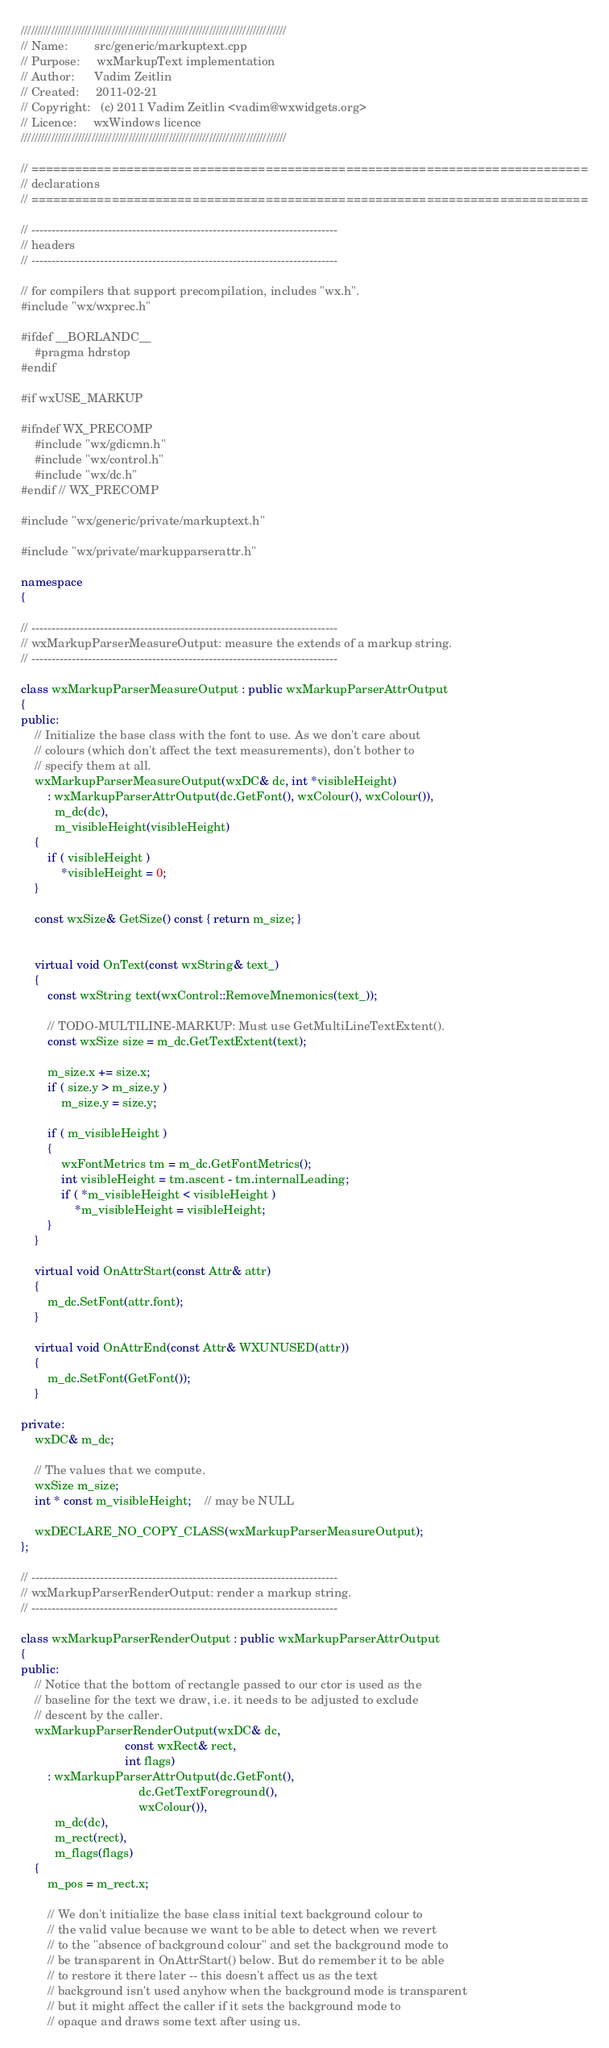<code> <loc_0><loc_0><loc_500><loc_500><_C++_>///////////////////////////////////////////////////////////////////////////////
// Name:        src/generic/markuptext.cpp
// Purpose:     wxMarkupText implementation
// Author:      Vadim Zeitlin
// Created:     2011-02-21
// Copyright:   (c) 2011 Vadim Zeitlin <vadim@wxwidgets.org>
// Licence:     wxWindows licence
///////////////////////////////////////////////////////////////////////////////

// ============================================================================
// declarations
// ============================================================================

// ----------------------------------------------------------------------------
// headers
// ----------------------------------------------------------------------------

// for compilers that support precompilation, includes "wx.h".
#include "wx/wxprec.h"

#ifdef __BORLANDC__
    #pragma hdrstop
#endif

#if wxUSE_MARKUP

#ifndef WX_PRECOMP
    #include "wx/gdicmn.h"
    #include "wx/control.h"
    #include "wx/dc.h"
#endif // WX_PRECOMP

#include "wx/generic/private/markuptext.h"

#include "wx/private/markupparserattr.h"

namespace
{

// ----------------------------------------------------------------------------
// wxMarkupParserMeasureOutput: measure the extends of a markup string.
// ----------------------------------------------------------------------------

class wxMarkupParserMeasureOutput : public wxMarkupParserAttrOutput
{
public:
    // Initialize the base class with the font to use. As we don't care about
    // colours (which don't affect the text measurements), don't bother to
    // specify them at all.
    wxMarkupParserMeasureOutput(wxDC& dc, int *visibleHeight)
        : wxMarkupParserAttrOutput(dc.GetFont(), wxColour(), wxColour()),
          m_dc(dc),
          m_visibleHeight(visibleHeight)
    {
        if ( visibleHeight )
            *visibleHeight = 0;
    }

    const wxSize& GetSize() const { return m_size; }


    virtual void OnText(const wxString& text_)
    {
        const wxString text(wxControl::RemoveMnemonics(text_));

        // TODO-MULTILINE-MARKUP: Must use GetMultiLineTextExtent().
        const wxSize size = m_dc.GetTextExtent(text);

        m_size.x += size.x;
        if ( size.y > m_size.y )
            m_size.y = size.y;

        if ( m_visibleHeight )
        {
            wxFontMetrics tm = m_dc.GetFontMetrics();
            int visibleHeight = tm.ascent - tm.internalLeading;
            if ( *m_visibleHeight < visibleHeight )
                *m_visibleHeight = visibleHeight;
        }
    }

    virtual void OnAttrStart(const Attr& attr)
    {
        m_dc.SetFont(attr.font);
    }

    virtual void OnAttrEnd(const Attr& WXUNUSED(attr))
    {
        m_dc.SetFont(GetFont());
    }

private:
    wxDC& m_dc;

    // The values that we compute.
    wxSize m_size;
    int * const m_visibleHeight;    // may be NULL

    wxDECLARE_NO_COPY_CLASS(wxMarkupParserMeasureOutput);
};

// ----------------------------------------------------------------------------
// wxMarkupParserRenderOutput: render a markup string.
// ----------------------------------------------------------------------------

class wxMarkupParserRenderOutput : public wxMarkupParserAttrOutput
{
public:
    // Notice that the bottom of rectangle passed to our ctor is used as the
    // baseline for the text we draw, i.e. it needs to be adjusted to exclude
    // descent by the caller.
    wxMarkupParserRenderOutput(wxDC& dc,
                               const wxRect& rect,
                               int flags)
        : wxMarkupParserAttrOutput(dc.GetFont(),
                                   dc.GetTextForeground(),
                                   wxColour()),
          m_dc(dc),
          m_rect(rect),
          m_flags(flags)
    {
        m_pos = m_rect.x;

        // We don't initialize the base class initial text background colour to
        // the valid value because we want to be able to detect when we revert
        // to the "absence of background colour" and set the background mode to
        // be transparent in OnAttrStart() below. But do remember it to be able
        // to restore it there later -- this doesn't affect us as the text
        // background isn't used anyhow when the background mode is transparent
        // but it might affect the caller if it sets the background mode to
        // opaque and draws some text after using us.</code> 